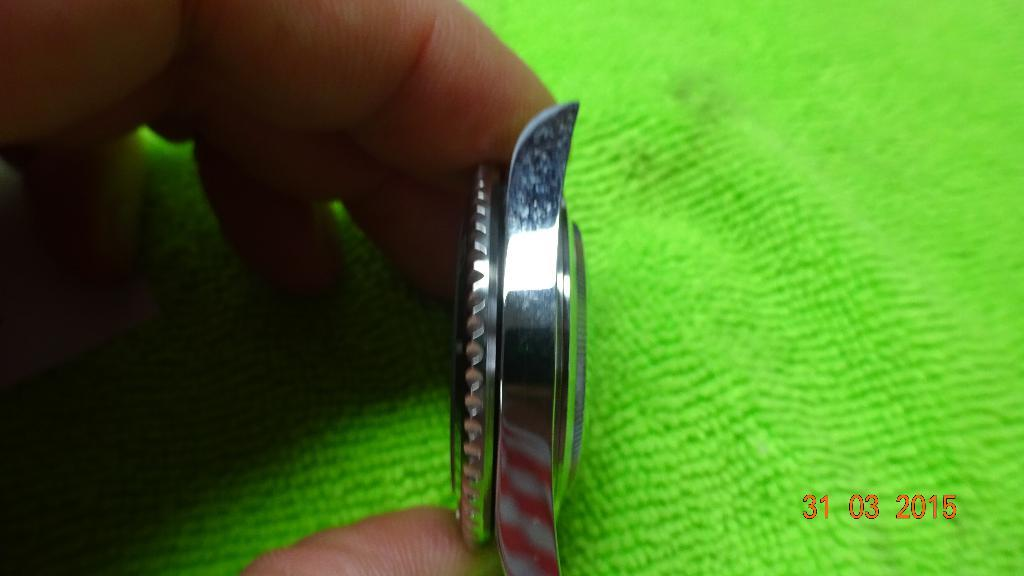<image>
Share a concise interpretation of the image provided. Person holding a silver object that has the date of March 31 on the bottom. 